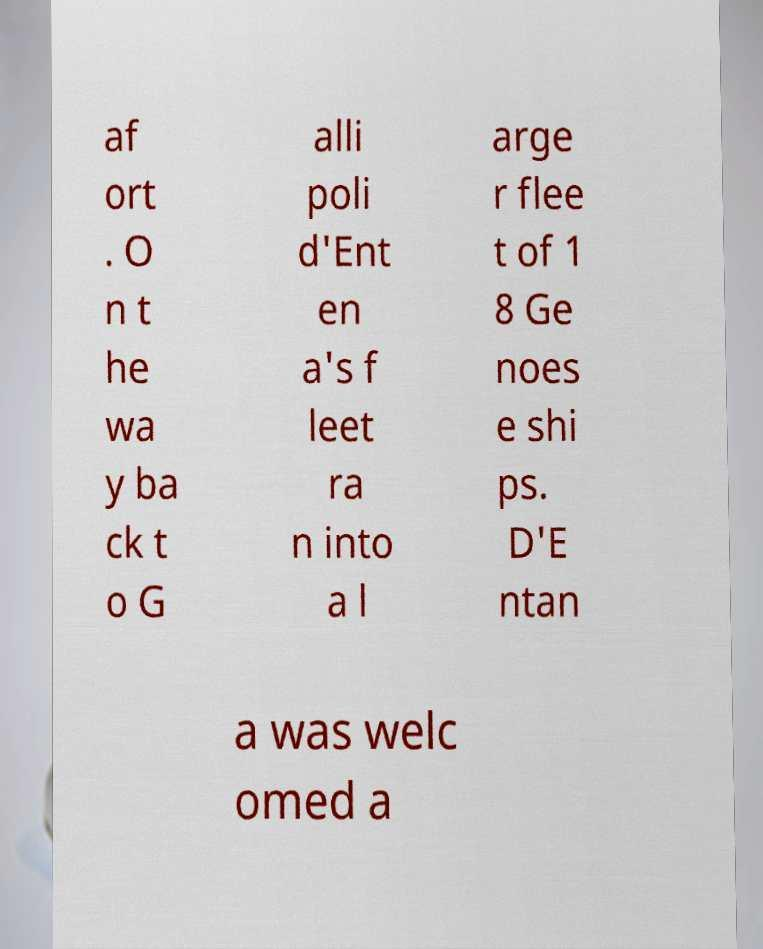Please read and relay the text visible in this image. What does it say? af ort . O n t he wa y ba ck t o G alli poli d'Ent en a's f leet ra n into a l arge r flee t of 1 8 Ge noes e shi ps. D'E ntan a was welc omed a 